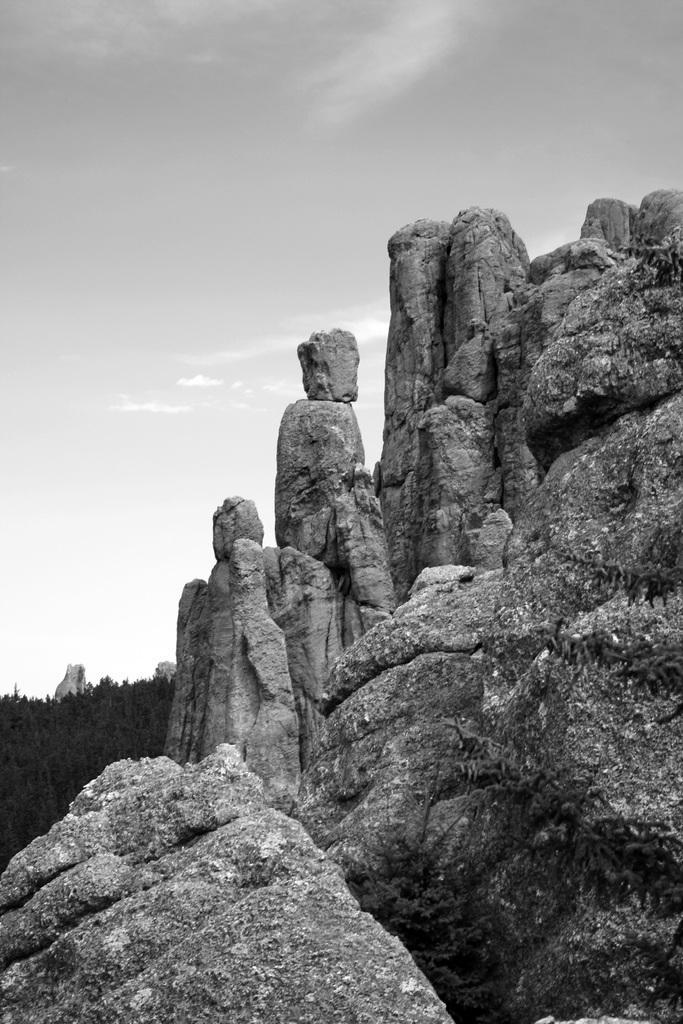How would you summarize this image in a sentence or two? In this picture there are few mountains in the right corner and there are few trees in the left corner. 